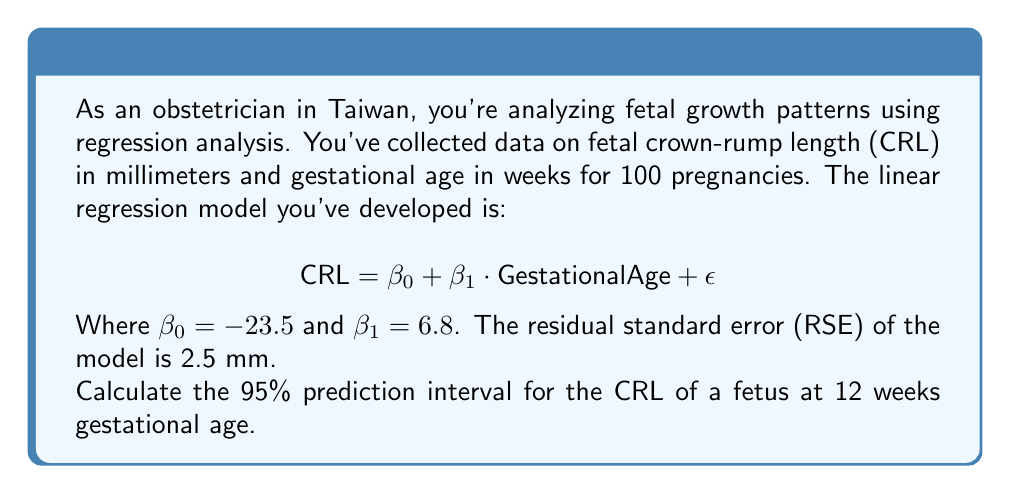Could you help me with this problem? To calculate the 95% prediction interval, we'll follow these steps:

1) First, let's calculate the point estimate for CRL at 12 weeks:

   $$ \text{CRL} = -23.5 + 6.8 \cdot 12 = 58.1 \text{ mm} $$

2) The general formula for a prediction interval is:

   $$ \hat{y} \pm t_{n-2, \alpha/2} \cdot RSE \cdot \sqrt{1 + \frac{1}{n} + \frac{(x - \bar{x})^2}{\sum(x_i - \bar{x})^2}} $$

   Where:
   - $\hat{y}$ is the point estimate (58.1 mm)
   - $t_{n-2, \alpha/2}$ is the t-value for 98 degrees of freedom (n-2) and $\alpha = 0.05$ for a 95% interval
   - RSE is the residual standard error (2.5 mm)
   - $n$ is the sample size (100)
   - $x$ is the predictor value (12 weeks)
   - $\bar{x}$ is the mean of the predictor values
   - $\sum(x_i - \bar{x})^2$ is the sum of squared deviations of predictor values

3) We don't have all the information to calculate the exact value of the last term under the square root. However, for a large sample size and a predictor value not far from the mean, this term is often close to 1. So, we'll approximate it as:

   $$ \sqrt{1 + \frac{1}{n} + \frac{(x - \bar{x})^2}{\sum(x_i - \bar{x})^2}} \approx \sqrt{1 + \frac{1}{100}} \approx 1.005 $$

4) The t-value for 98 degrees of freedom and $\alpha = 0.05$ is approximately 1.984.

5) Now we can calculate the interval:

   $$ 58.1 \pm 1.984 \cdot 2.5 \cdot 1.005 $$
   $$ 58.1 \pm 4.98 $$

Therefore, the 95% prediction interval is approximately (53.12 mm, 63.08 mm).
Answer: The 95% prediction interval for the crown-rump length of a fetus at 12 weeks gestational age is approximately (53.12 mm, 63.08 mm). 